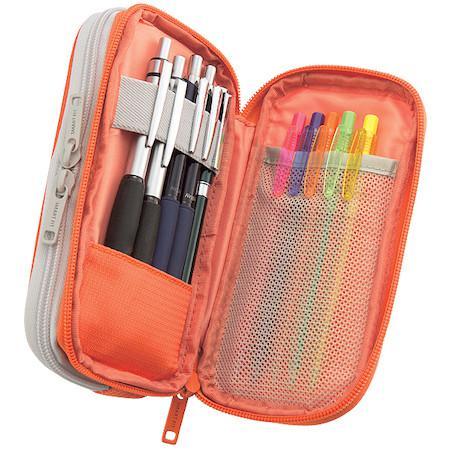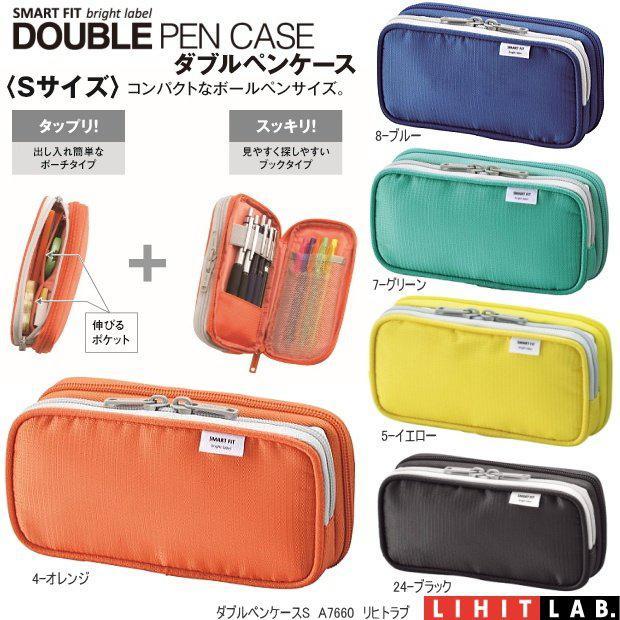The first image is the image on the left, the second image is the image on the right. Examine the images to the left and right. Is the description "Two blue cases are open, exposing the contents." accurate? Answer yes or no. No. The first image is the image on the left, the second image is the image on the right. Evaluate the accuracy of this statement regarding the images: "An image shows a hand opening a blue pencil case.". Is it true? Answer yes or no. No. 